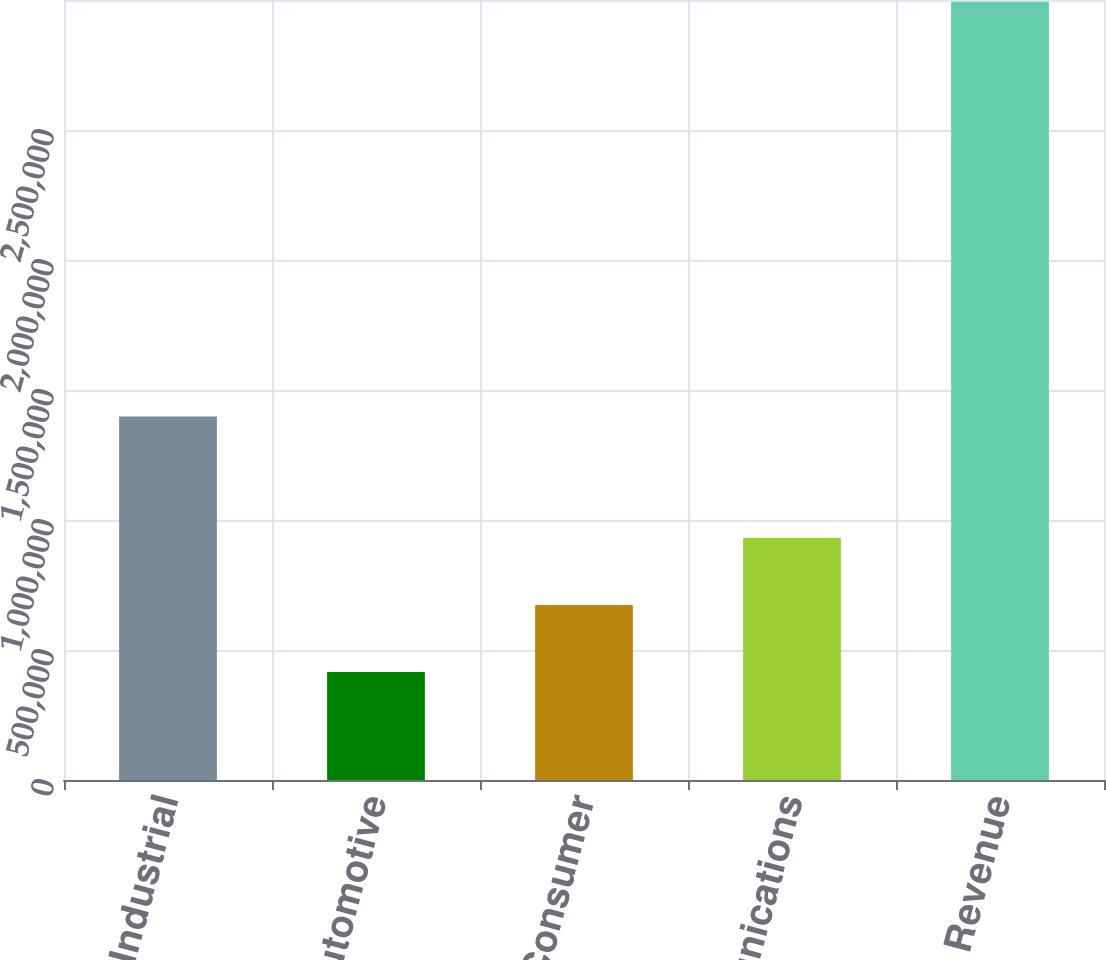<chart> <loc_0><loc_0><loc_500><loc_500><bar_chart><fcel>Industrial<fcel>Automotive<fcel>Consumer<fcel>Communications<fcel>Total Revenue<nl><fcel>1.39763e+06<fcel>415444<fcel>673232<fcel>931019<fcel>2.99332e+06<nl></chart> 